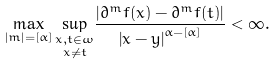<formula> <loc_0><loc_0><loc_500><loc_500>\max _ { \left | m \right | = [ \alpha ] } \underset { x \neq t } { \sup _ { x , t \in \omega } } \frac { \left | \partial ^ { m } f ( x ) - \partial ^ { m } f ( t ) \right | } { \left | x - y \right | ^ { \alpha - [ \alpha ] } } < \infty .</formula> 